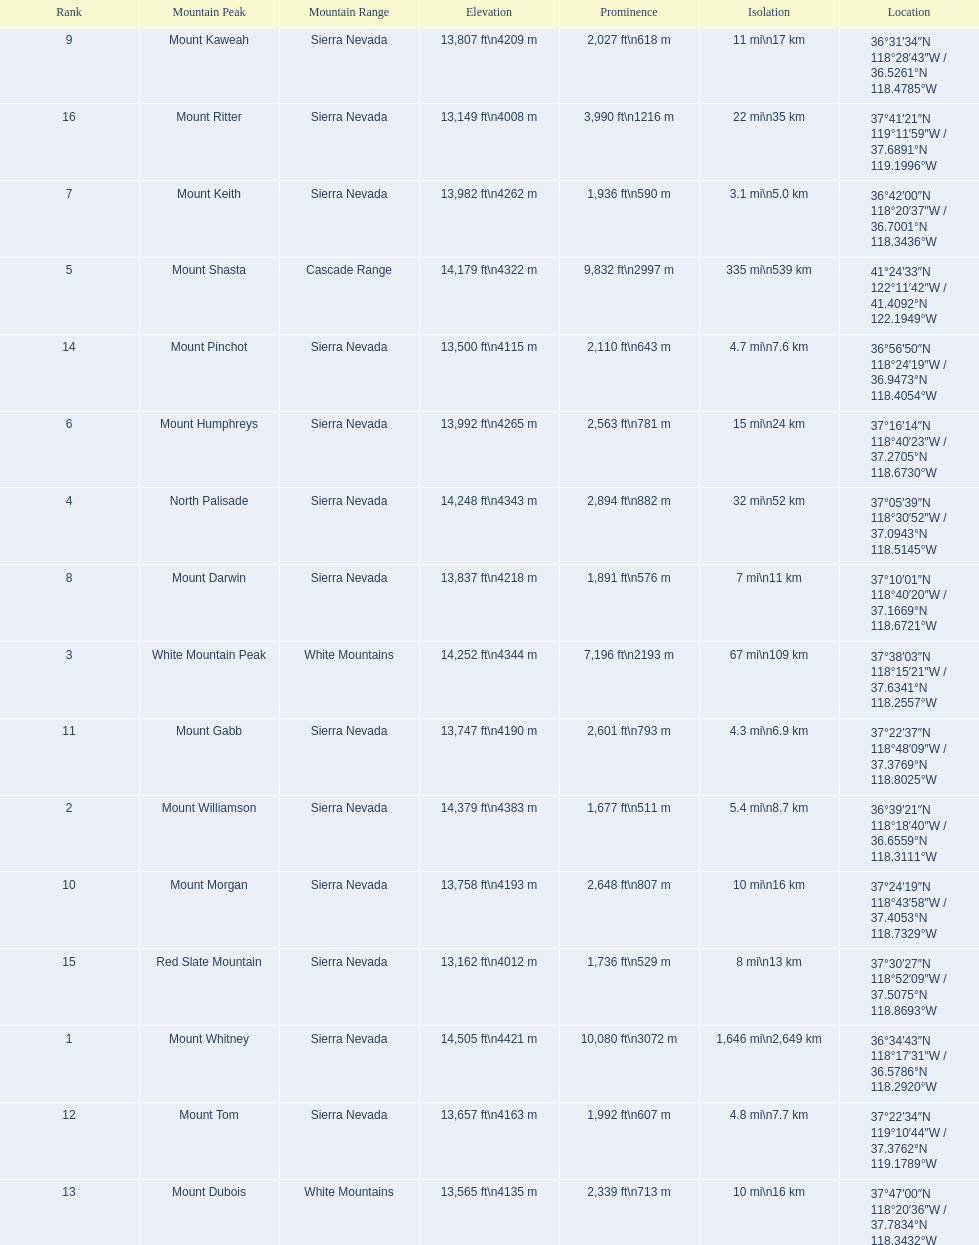What are the mountain peaks? Mount Whitney, Mount Williamson, White Mountain Peak, North Palisade, Mount Shasta, Mount Humphreys, Mount Keith, Mount Darwin, Mount Kaweah, Mount Morgan, Mount Gabb, Mount Tom, Mount Dubois, Mount Pinchot, Red Slate Mountain, Mount Ritter. Of these, which one has a prominence more than 10,000 ft? Mount Whitney. 